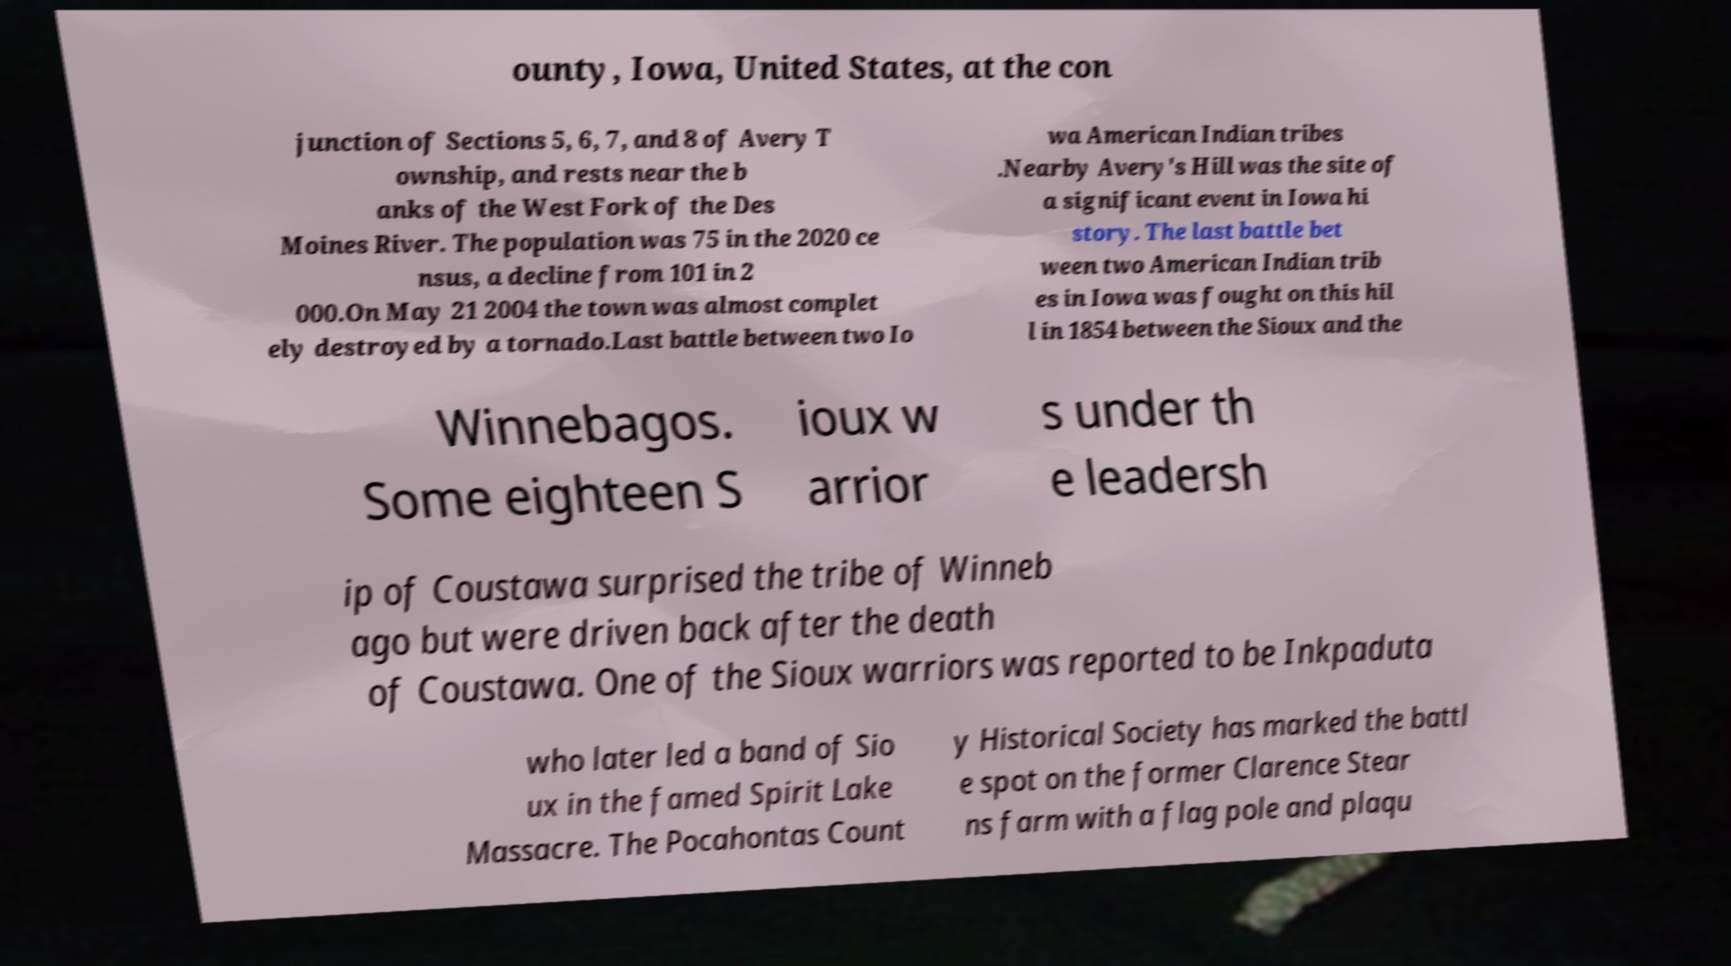For documentation purposes, I need the text within this image transcribed. Could you provide that? ounty, Iowa, United States, at the con junction of Sections 5, 6, 7, and 8 of Avery T ownship, and rests near the b anks of the West Fork of the Des Moines River. The population was 75 in the 2020 ce nsus, a decline from 101 in 2 000.On May 21 2004 the town was almost complet ely destroyed by a tornado.Last battle between two Io wa American Indian tribes .Nearby Avery's Hill was the site of a significant event in Iowa hi story. The last battle bet ween two American Indian trib es in Iowa was fought on this hil l in 1854 between the Sioux and the Winnebagos. Some eighteen S ioux w arrior s under th e leadersh ip of Coustawa surprised the tribe of Winneb ago but were driven back after the death of Coustawa. One of the Sioux warriors was reported to be Inkpaduta who later led a band of Sio ux in the famed Spirit Lake Massacre. The Pocahontas Count y Historical Society has marked the battl e spot on the former Clarence Stear ns farm with a flag pole and plaqu 